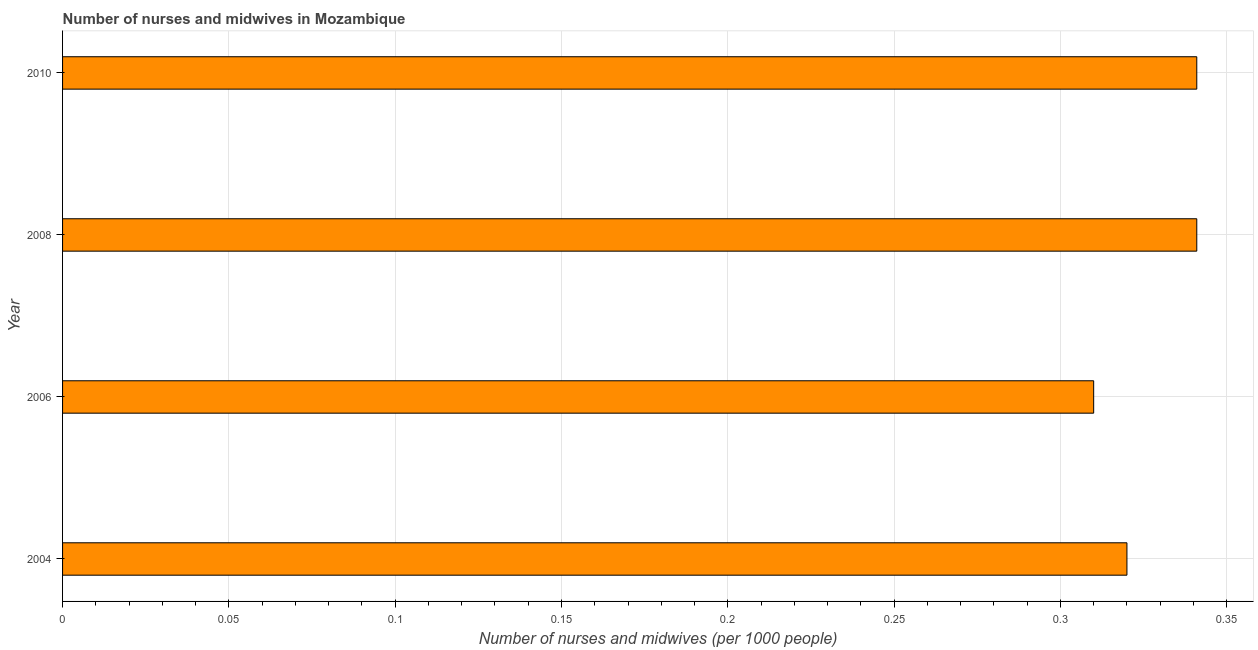Does the graph contain any zero values?
Keep it short and to the point. No. What is the title of the graph?
Your answer should be very brief. Number of nurses and midwives in Mozambique. What is the label or title of the X-axis?
Your response must be concise. Number of nurses and midwives (per 1000 people). What is the label or title of the Y-axis?
Offer a terse response. Year. What is the number of nurses and midwives in 2004?
Your answer should be compact. 0.32. Across all years, what is the maximum number of nurses and midwives?
Ensure brevity in your answer.  0.34. Across all years, what is the minimum number of nurses and midwives?
Offer a terse response. 0.31. In which year was the number of nurses and midwives minimum?
Provide a short and direct response. 2006. What is the sum of the number of nurses and midwives?
Your response must be concise. 1.31. What is the difference between the number of nurses and midwives in 2004 and 2008?
Provide a succinct answer. -0.02. What is the average number of nurses and midwives per year?
Provide a succinct answer. 0.33. What is the median number of nurses and midwives?
Offer a very short reply. 0.33. In how many years, is the number of nurses and midwives greater than 0.18 ?
Provide a succinct answer. 4. Do a majority of the years between 2010 and 2004 (inclusive) have number of nurses and midwives greater than 0.17 ?
Provide a succinct answer. Yes. What is the ratio of the number of nurses and midwives in 2006 to that in 2008?
Offer a very short reply. 0.91. Is the difference between the number of nurses and midwives in 2004 and 2006 greater than the difference between any two years?
Offer a terse response. No. Is the sum of the number of nurses and midwives in 2008 and 2010 greater than the maximum number of nurses and midwives across all years?
Offer a very short reply. Yes. What is the difference between the highest and the lowest number of nurses and midwives?
Offer a terse response. 0.03. How many bars are there?
Give a very brief answer. 4. Are all the bars in the graph horizontal?
Your answer should be very brief. Yes. Are the values on the major ticks of X-axis written in scientific E-notation?
Ensure brevity in your answer.  No. What is the Number of nurses and midwives (per 1000 people) in 2004?
Ensure brevity in your answer.  0.32. What is the Number of nurses and midwives (per 1000 people) of 2006?
Ensure brevity in your answer.  0.31. What is the Number of nurses and midwives (per 1000 people) in 2008?
Make the answer very short. 0.34. What is the Number of nurses and midwives (per 1000 people) of 2010?
Your answer should be compact. 0.34. What is the difference between the Number of nurses and midwives (per 1000 people) in 2004 and 2006?
Provide a succinct answer. 0.01. What is the difference between the Number of nurses and midwives (per 1000 people) in 2004 and 2008?
Provide a short and direct response. -0.02. What is the difference between the Number of nurses and midwives (per 1000 people) in 2004 and 2010?
Your answer should be compact. -0.02. What is the difference between the Number of nurses and midwives (per 1000 people) in 2006 and 2008?
Ensure brevity in your answer.  -0.03. What is the difference between the Number of nurses and midwives (per 1000 people) in 2006 and 2010?
Your answer should be very brief. -0.03. What is the ratio of the Number of nurses and midwives (per 1000 people) in 2004 to that in 2006?
Offer a terse response. 1.03. What is the ratio of the Number of nurses and midwives (per 1000 people) in 2004 to that in 2008?
Provide a short and direct response. 0.94. What is the ratio of the Number of nurses and midwives (per 1000 people) in 2004 to that in 2010?
Ensure brevity in your answer.  0.94. What is the ratio of the Number of nurses and midwives (per 1000 people) in 2006 to that in 2008?
Ensure brevity in your answer.  0.91. What is the ratio of the Number of nurses and midwives (per 1000 people) in 2006 to that in 2010?
Your response must be concise. 0.91. 